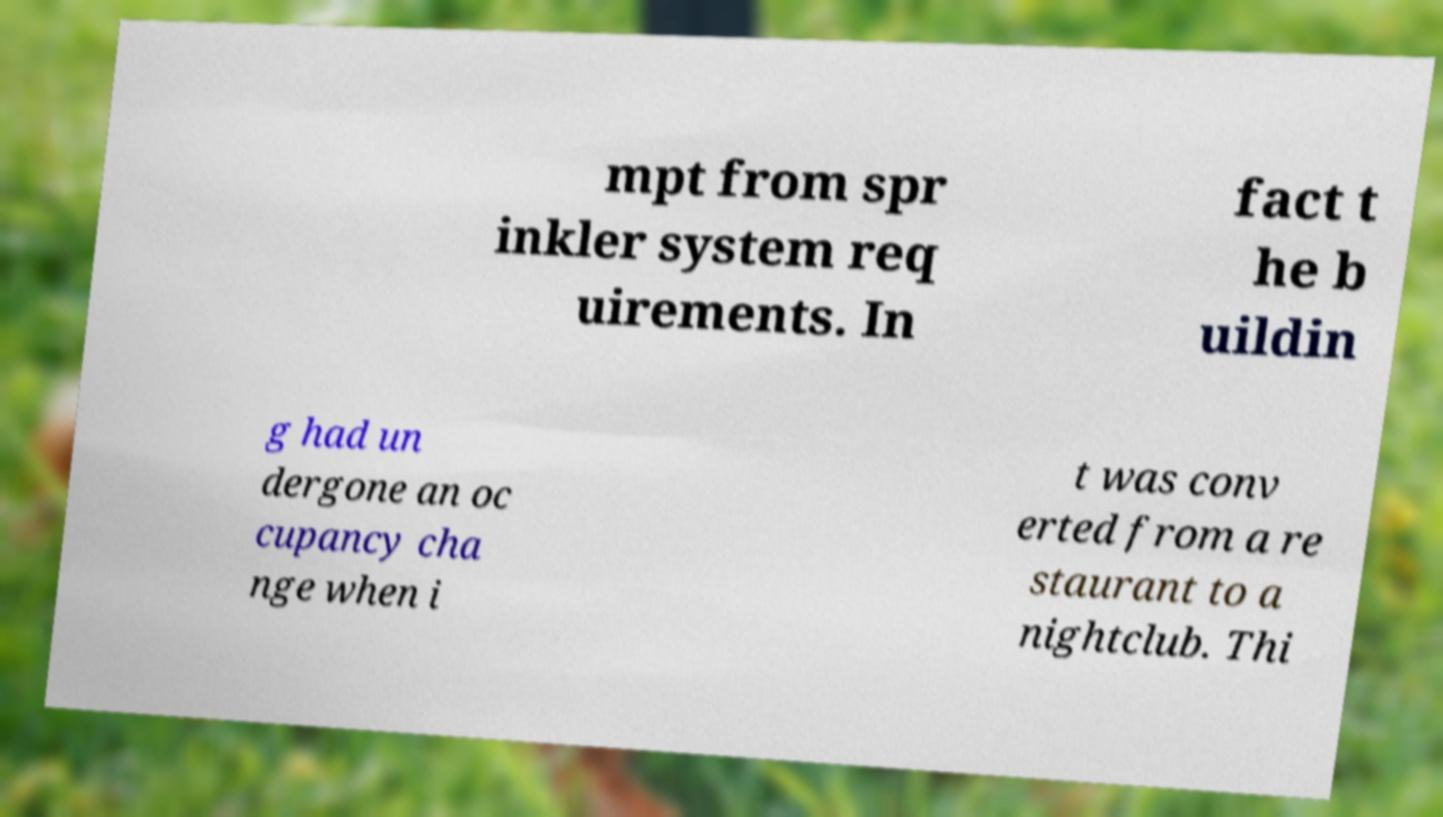Can you read and provide the text displayed in the image?This photo seems to have some interesting text. Can you extract and type it out for me? mpt from spr inkler system req uirements. In fact t he b uildin g had un dergone an oc cupancy cha nge when i t was conv erted from a re staurant to a nightclub. Thi 